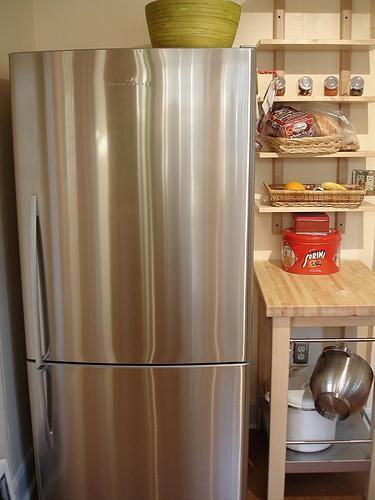How many bowls are there?
Give a very brief answer. 2. How many windows are on the train in the picture?
Give a very brief answer. 0. 